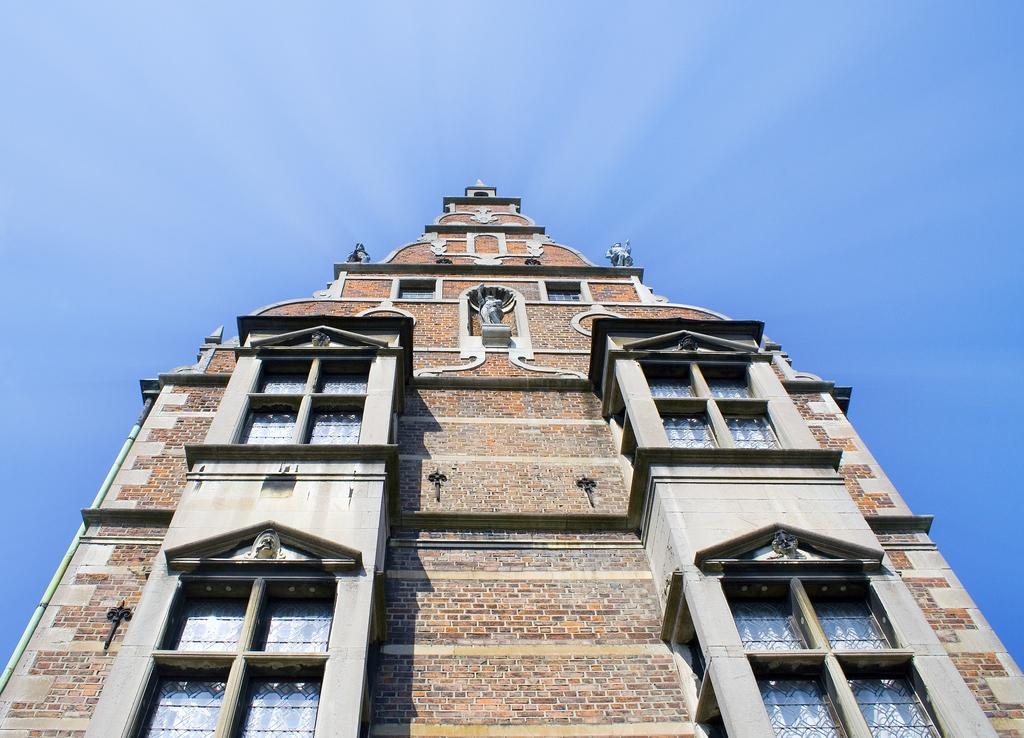What type of structure is present in the picture? There is a building in the picture. What material is the building made of? The building is made up of bricks. What architectural features can be seen on the building? The building has windows. What is visible at the top of the picture? The sky is visible at the top of the picture. What is the color of the sky in the image? The color of the sky is blue. Can you see any kettles floating in the blue sky in the image? No, there are no kettles visible in the sky in the image. 